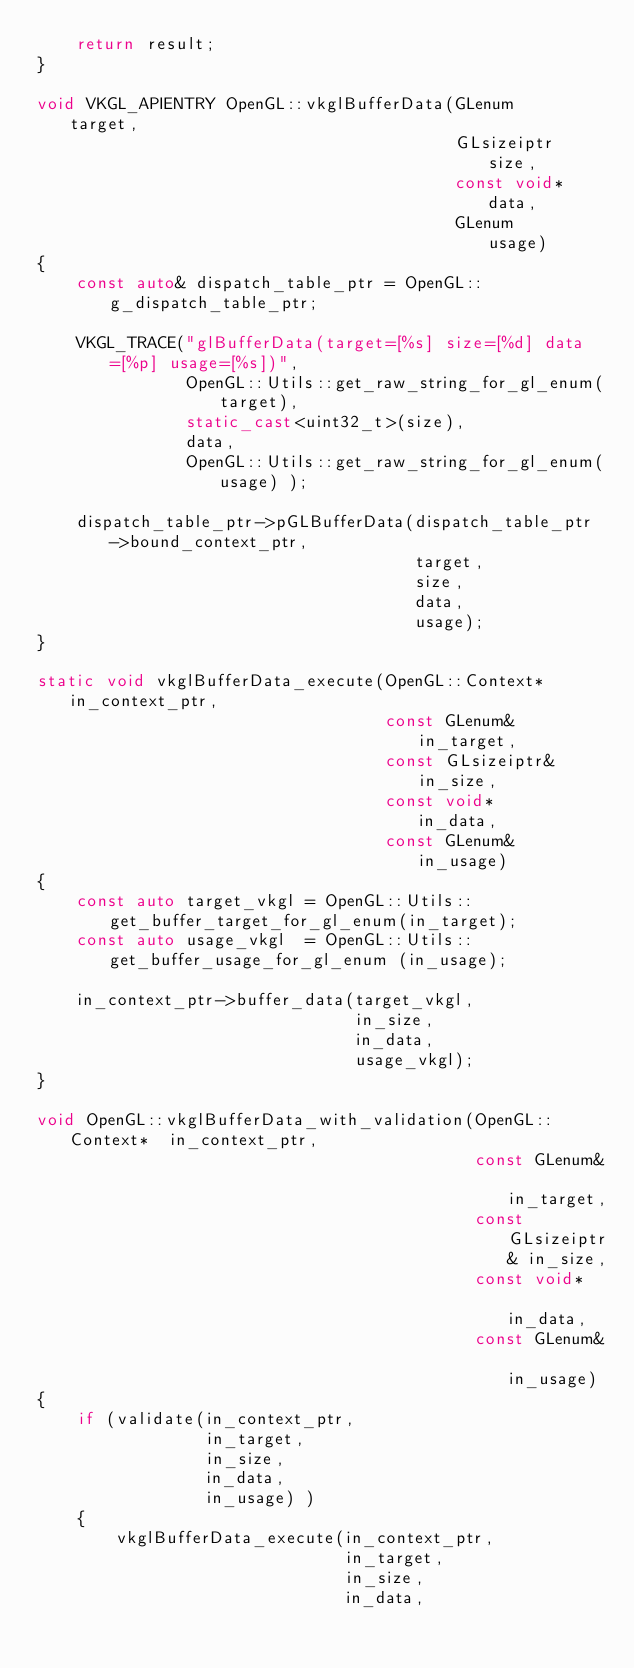Convert code to text. <code><loc_0><loc_0><loc_500><loc_500><_C++_>    return result;
}

void VKGL_APIENTRY OpenGL::vkglBufferData(GLenum      target,
                                          GLsizeiptr  size,
                                          const void* data,
                                          GLenum      usage)
{
    const auto& dispatch_table_ptr = OpenGL::g_dispatch_table_ptr;

    VKGL_TRACE("glBufferData(target=[%s] size=[%d] data=[%p] usage=[%s])",
               OpenGL::Utils::get_raw_string_for_gl_enum(target),
               static_cast<uint32_t>(size),
               data,
               OpenGL::Utils::get_raw_string_for_gl_enum(usage) );

    dispatch_table_ptr->pGLBufferData(dispatch_table_ptr->bound_context_ptr,
                                      target,
                                      size,
                                      data,
                                      usage);
}

static void vkglBufferData_execute(OpenGL::Context*  in_context_ptr,
                                   const GLenum&     in_target,
                                   const GLsizeiptr& in_size,
                                   const void*       in_data,
                                   const GLenum&     in_usage)
{
    const auto target_vkgl = OpenGL::Utils::get_buffer_target_for_gl_enum(in_target);
    const auto usage_vkgl  = OpenGL::Utils::get_buffer_usage_for_gl_enum (in_usage);

    in_context_ptr->buffer_data(target_vkgl,
                                in_size,
                                in_data,
                                usage_vkgl);
}

void OpenGL::vkglBufferData_with_validation(OpenGL::Context*  in_context_ptr,
                                            const GLenum&     in_target,
                                            const GLsizeiptr& in_size,
                                            const void*       in_data,
                                            const GLenum&     in_usage)
{
    if (validate(in_context_ptr,
                 in_target,
                 in_size,
                 in_data,
                 in_usage) )
    {
        vkglBufferData_execute(in_context_ptr,
                               in_target,
                               in_size,
                               in_data,</code> 